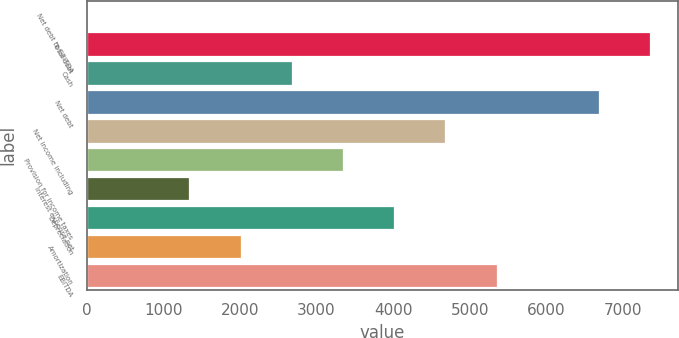Convert chart. <chart><loc_0><loc_0><loc_500><loc_500><bar_chart><fcel>Net debt to EBITDA<fcel>Total debt<fcel>Cash<fcel>Net debt<fcel>Net income including<fcel>Provision for income taxes<fcel>Interest expense net<fcel>Depreciation<fcel>Amortization<fcel>EBITDA<nl><fcel>2.3<fcel>7355.47<fcel>2676.18<fcel>6687<fcel>4681.59<fcel>3344.65<fcel>1339.24<fcel>4013.12<fcel>2007.71<fcel>5350.06<nl></chart> 